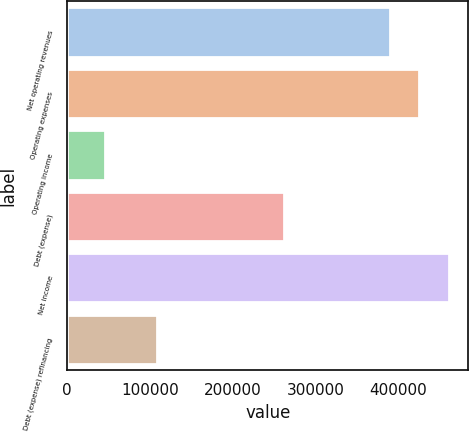<chart> <loc_0><loc_0><loc_500><loc_500><bar_chart><fcel>Net operating revenues<fcel>Operating expenses<fcel>Operating income<fcel>Debt (expense)<fcel>Net income<fcel>Debt (expense) refinancing<nl><fcel>389893<fcel>425827<fcel>45485<fcel>262650<fcel>461760<fcel>108918<nl></chart> 